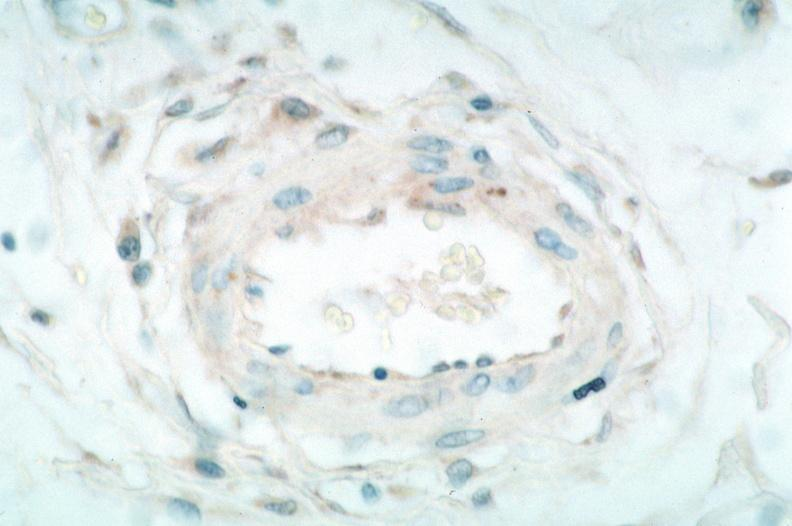s cardiovascular present?
Answer the question using a single word or phrase. Yes 